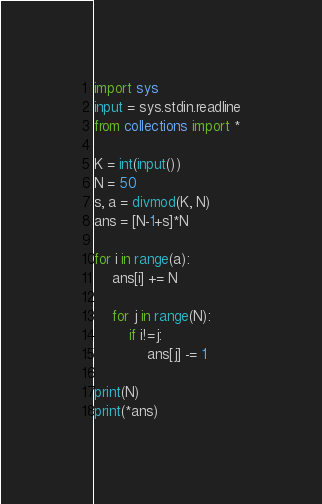<code> <loc_0><loc_0><loc_500><loc_500><_Python_>import sys
input = sys.stdin.readline
from collections import *

K = int(input())
N = 50
s, a = divmod(K, N)
ans = [N-1+s]*N

for i in range(a):
    ans[i] += N
    
    for j in range(N):
        if i!=j:
            ans[j] -= 1

print(N)
print(*ans)</code> 